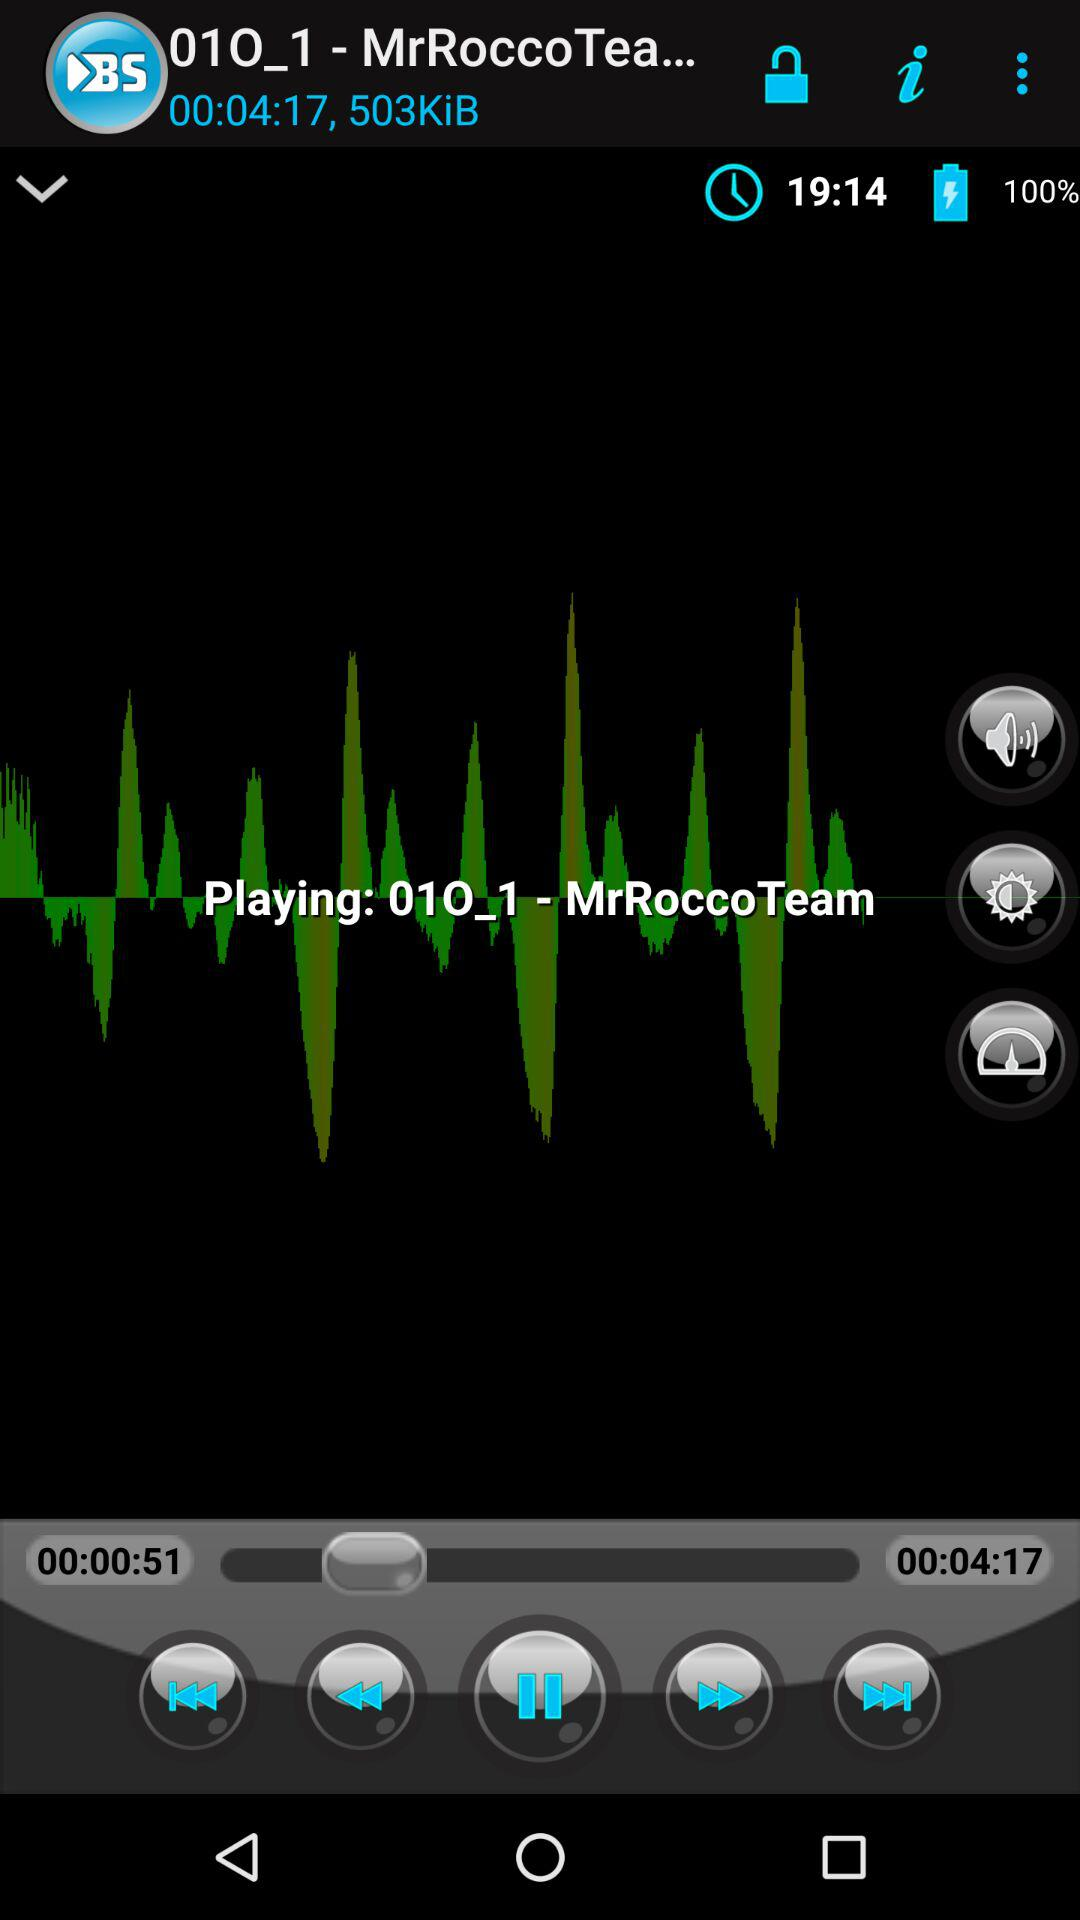Which song is playing on the screen? The song playing on the screen is "01O_1". 